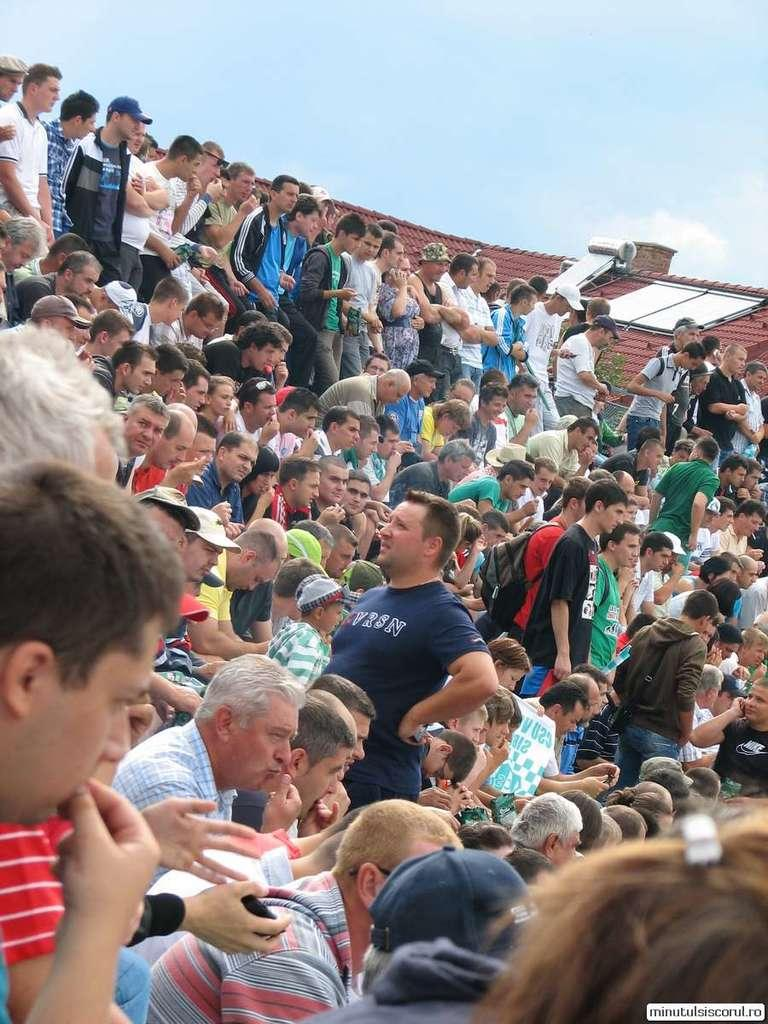What are the people in the image doing? Some people are standing, while others are sitting in the image. Where is the scene taking place? The image shows a rooftop. What can be seen at the top of the image? The sky is visible at the top of the image. How many apples are being served on the table in the image? There is no table or apples present in the image. What type of wine is being poured for the secretary in the image? There is no secretary or wine present in the image. 